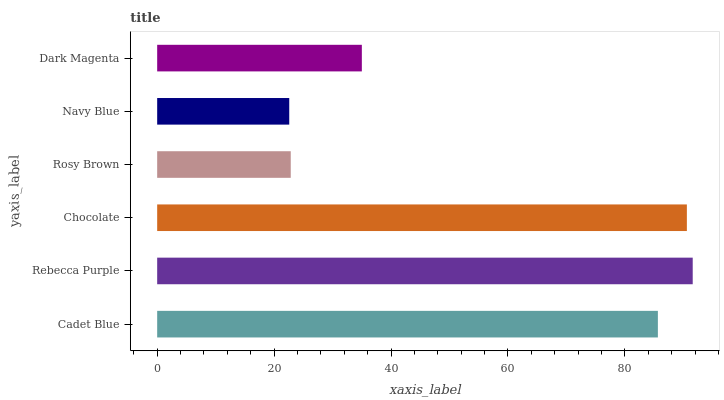Is Navy Blue the minimum?
Answer yes or no. Yes. Is Rebecca Purple the maximum?
Answer yes or no. Yes. Is Chocolate the minimum?
Answer yes or no. No. Is Chocolate the maximum?
Answer yes or no. No. Is Rebecca Purple greater than Chocolate?
Answer yes or no. Yes. Is Chocolate less than Rebecca Purple?
Answer yes or no. Yes. Is Chocolate greater than Rebecca Purple?
Answer yes or no. No. Is Rebecca Purple less than Chocolate?
Answer yes or no. No. Is Cadet Blue the high median?
Answer yes or no. Yes. Is Dark Magenta the low median?
Answer yes or no. Yes. Is Rosy Brown the high median?
Answer yes or no. No. Is Cadet Blue the low median?
Answer yes or no. No. 